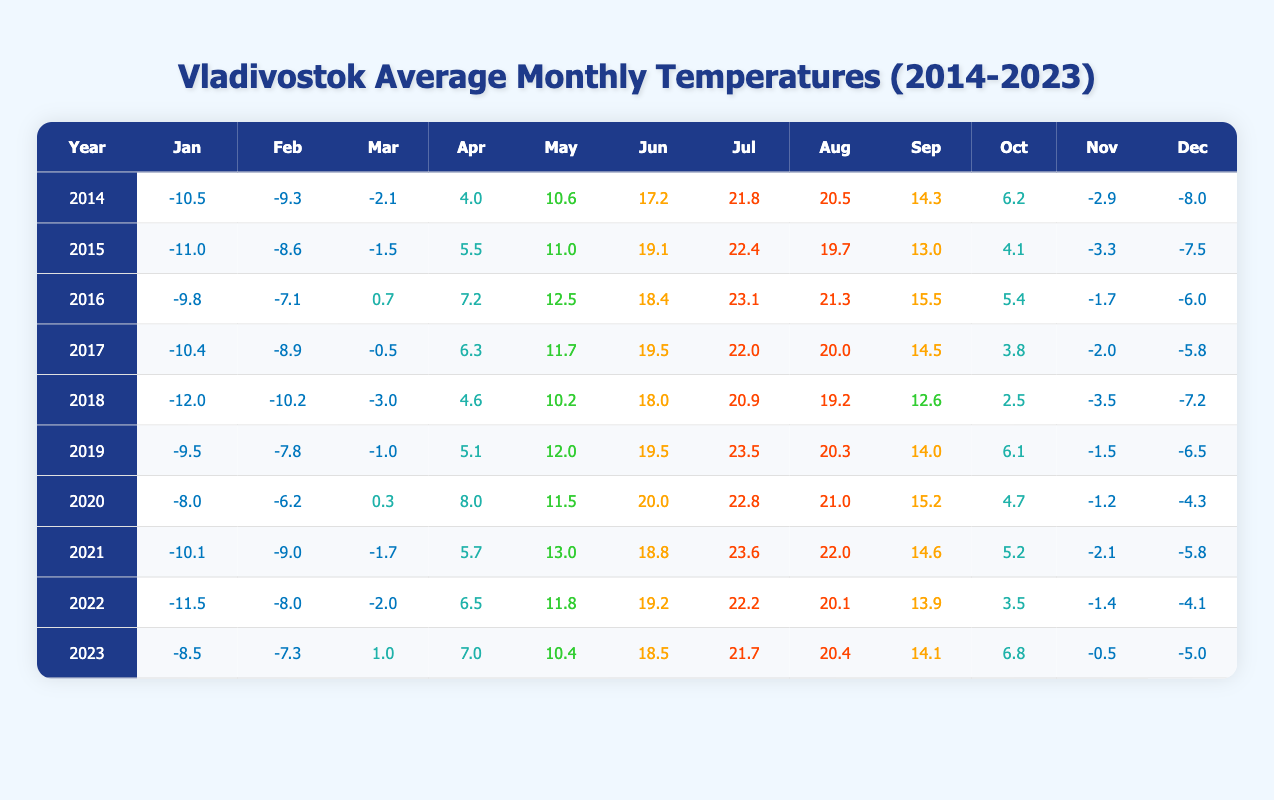What was the average temperature in July for the years 2020 and 2021? First, find the July temperatures for 2020 (22.8) and 2021 (23.6). Add these two values together: 22.8 + 23.6 = 46.4. Then, divide by 2 to get the average: 46.4 / 2 = 23.2.
Answer: 23.2 Which year had the coldest average temperature in January? Check each January temperature from 2014 to 2023: -10.5, -11.0, -9.8, -10.4, -12.0, -9.5, -8.0, -10.1, -11.5, and -8.5. The coldest value is -12.0 in 2018.
Answer: 2018 How did the average temperature in Vladivostok change from December 2014 to December 2023? Check the December temperatures: 2014 (-8.0) and 2023 (-5.0). Calculate the difference: -5.0 - (-8.0) = 3.0. The temperature increased by 3.0 degrees over these years.
Answer: Increased by 3.0 In which year was the highest average temperature recorded in June? Locate the June temperatures: 2014 (17.2), 2015 (19.1), 2016 (18.4), 2017 (19.5), 2018 (18.0), 2019 (19.5), 2020 (20.0), 2021 (18.8), 2022 (19.2), and 2023 (18.5). The highest value is 20.0 in 2020.
Answer: 2020 What is the median temperature for October across all years? List the October temperatures: 6.2, 4.1, 5.4, 3.8, 2.5, 6.1, 4.7, 5.2, 3.5, and 6.8. Arrange them in order: 2.5, 3.5, 3.8, 4.1, 4.7, 5.2, 5.4, 6.1, 6.2, 6.8. The median, being the average of the 5th and 6th values (4.7 and 5.2), is (4.7 + 5.2) / 2 = 4.95.
Answer: 4.95 Was the temperature in February 2016 warmer than the temperature in March 2018? The February 2016 temperature is -7.1 and the March 2018 temperature is -3.0. Since -7.1 is colder than -3.0, the statement is false.
Answer: No What was the total temperature increase from January 2023 to July 2023? January 2023 recorded -8.5 and July 2023 recorded 21.7. Calculate the total increase: 21.7 - (-8.5) = 30.2.
Answer: 30.2 Which year had a warmer average temperature in May: 2019 or 2020? The May temperatures are 2019 (12.0) and 2020 (11.5). Since 12.0 is greater than 11.5, 2019 was warmer.
Answer: 2019 How many years had average temperatures above 20 degrees in July? Check the July temperatures: 2014 (21.8), 2015 (22.4), 2016 (23.1), 2017 (22.0), 2018 (20.9), 2019 (23.5), 2020 (22.8), 2021 (23.6), 2022 (22.2), and 2023 (21.7). Count the years: ten total.
Answer: 10 What was the temperature difference between the hottest July (highest value) and the coldest December (lowest value) in this decade? Identify the hottest July (23.5 in 2019) and coldest December (-12.0 in 2018). Calculate the difference: 23.5 - (-12.0) = 35.5 degrees.
Answer: 35.5 